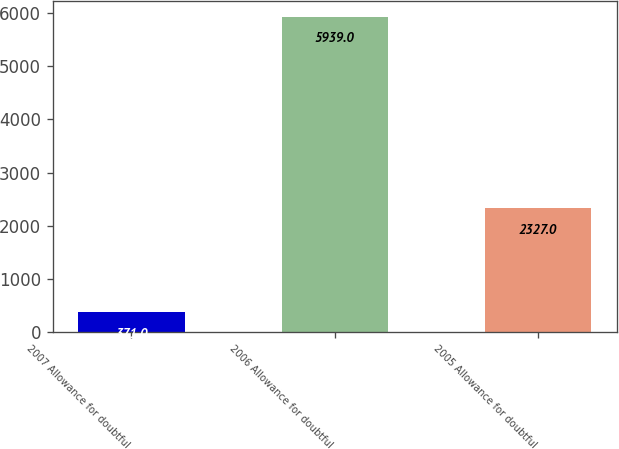Convert chart. <chart><loc_0><loc_0><loc_500><loc_500><bar_chart><fcel>2007 Allowance for doubtful<fcel>2006 Allowance for doubtful<fcel>2005 Allowance for doubtful<nl><fcel>371<fcel>5939<fcel>2327<nl></chart> 